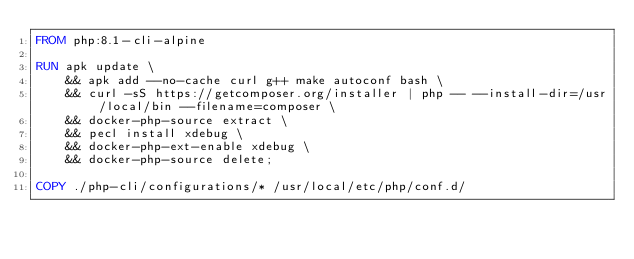<code> <loc_0><loc_0><loc_500><loc_500><_Dockerfile_>FROM php:8.1-cli-alpine

RUN apk update \
    && apk add --no-cache curl g++ make autoconf bash \
    && curl -sS https://getcomposer.org/installer | php -- --install-dir=/usr/local/bin --filename=composer \
    && docker-php-source extract \
    && pecl install xdebug \
    && docker-php-ext-enable xdebug \
    && docker-php-source delete;

COPY ./php-cli/configurations/* /usr/local/etc/php/conf.d/</code> 